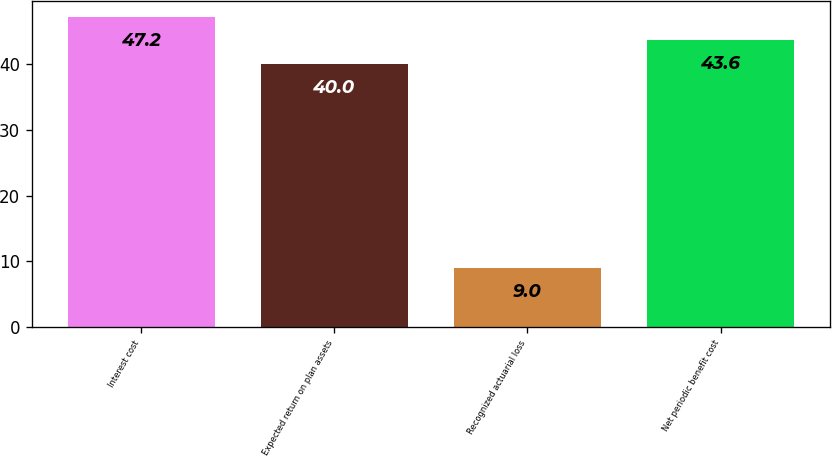Convert chart to OTSL. <chart><loc_0><loc_0><loc_500><loc_500><bar_chart><fcel>Interest cost<fcel>Expected return on plan assets<fcel>Recognized actuarial loss<fcel>Net periodic benefit cost<nl><fcel>47.2<fcel>40<fcel>9<fcel>43.6<nl></chart> 